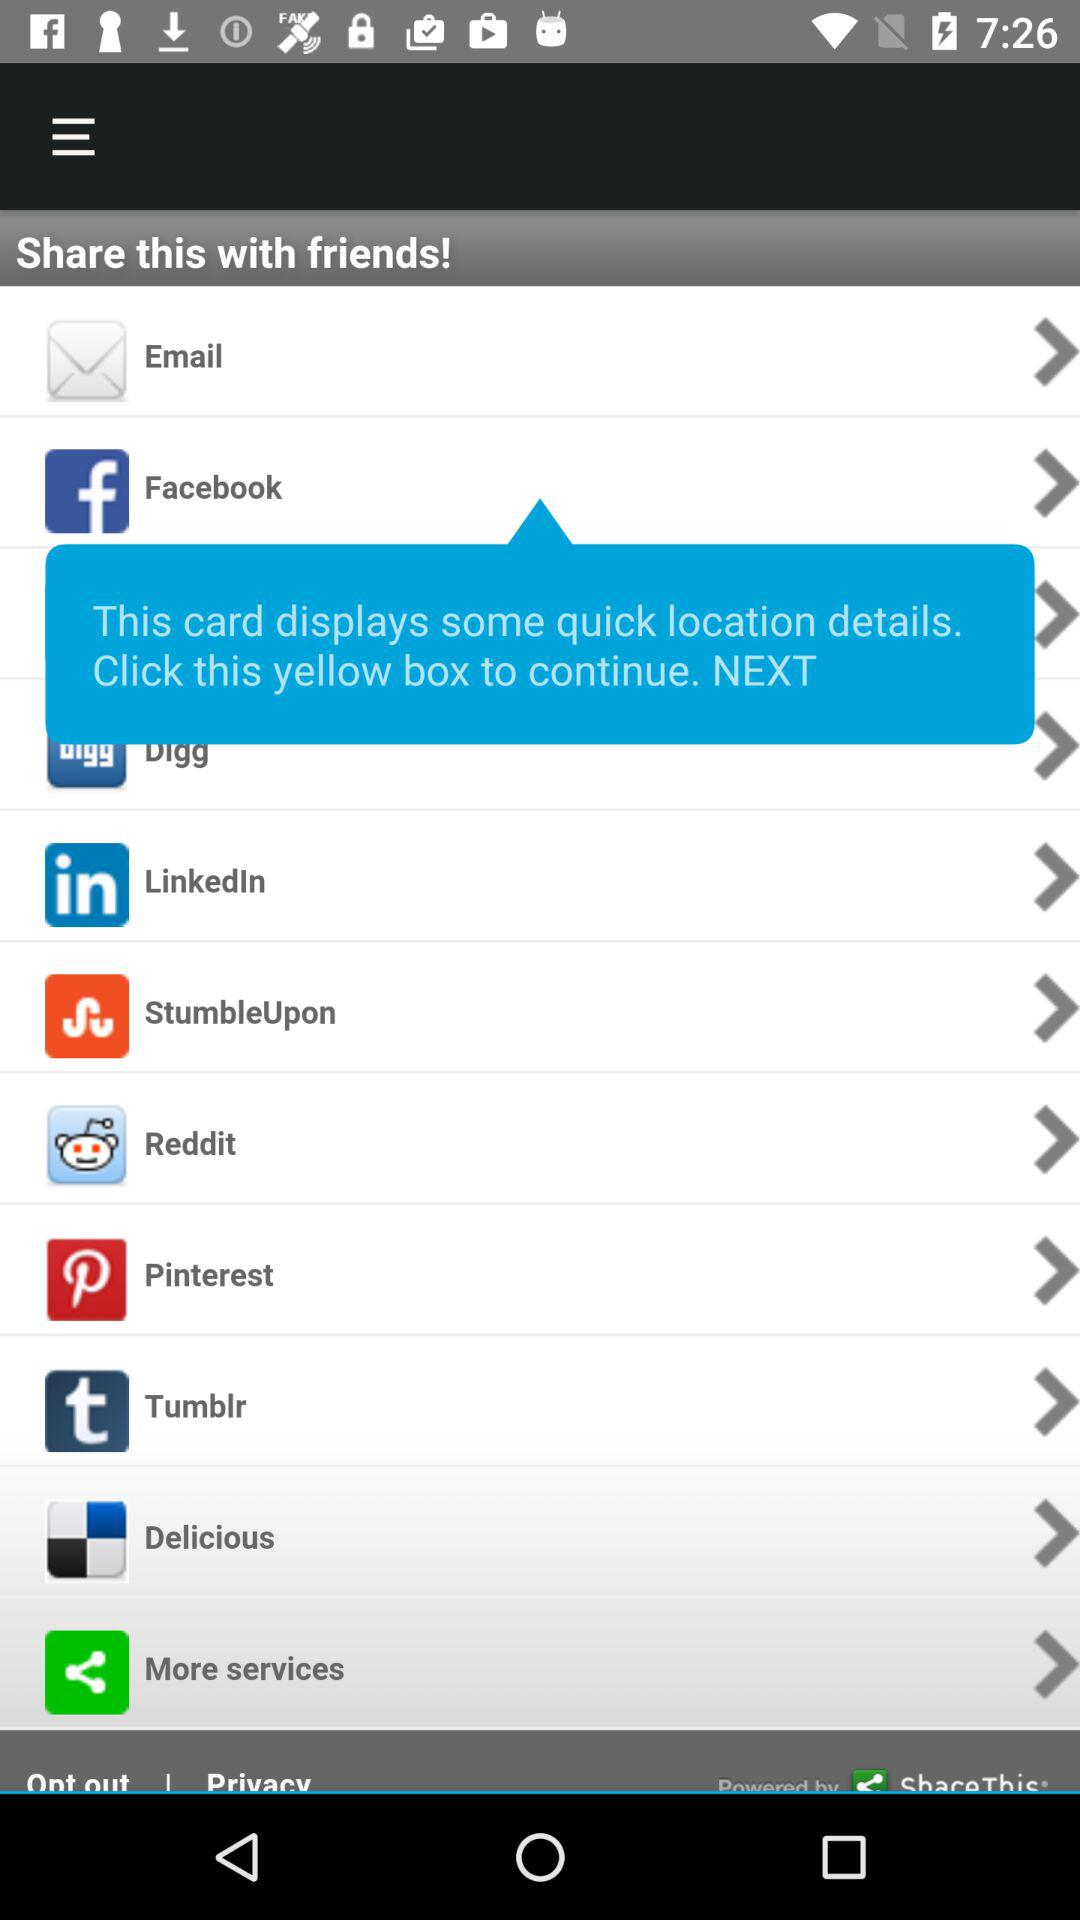By which app can we share this? You can share this by "Facebook", "Digg", "LinkedIn", "StumbleUpon", "Reddit", "Pinterest", "Tumblr" and "Delicious". 